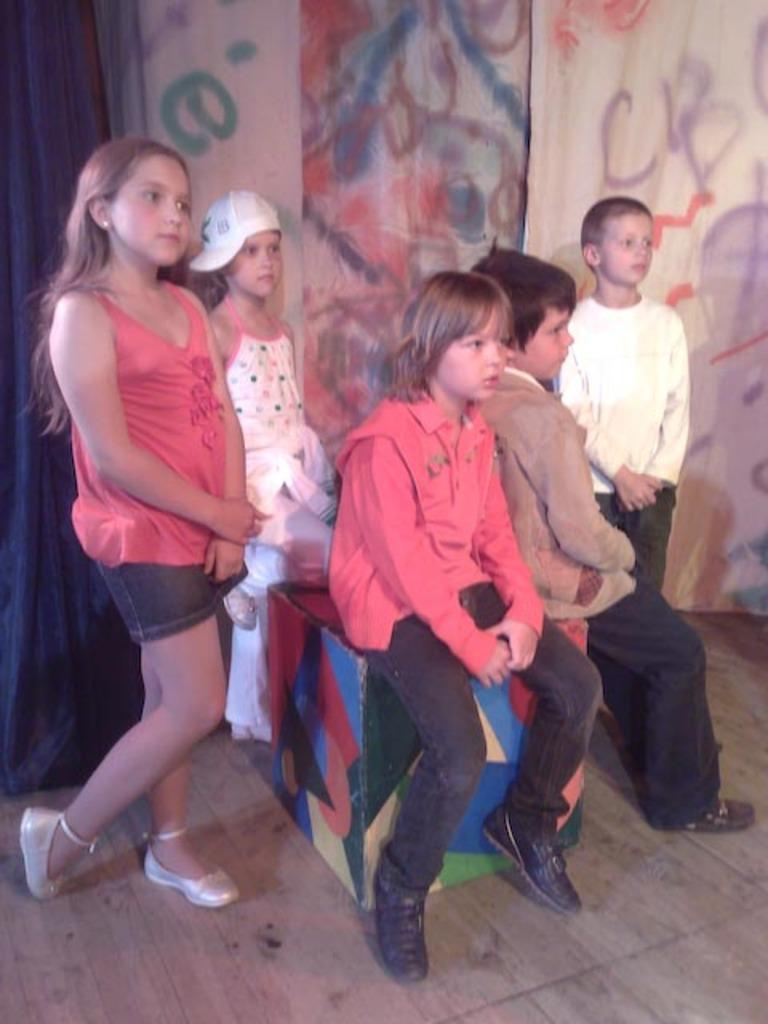How many children are present in the image? There are five children in the image. What are the boys in the image doing? Two boys are sitting in the image. What are the other children doing in the image? Three children are standing in the image. What can be seen on the left side of the image? There is a blue curtain on the left side of the image. What is the purpose of the beginner in the image? There is no mention of a beginner in the image, so we cannot determine its purpose. 